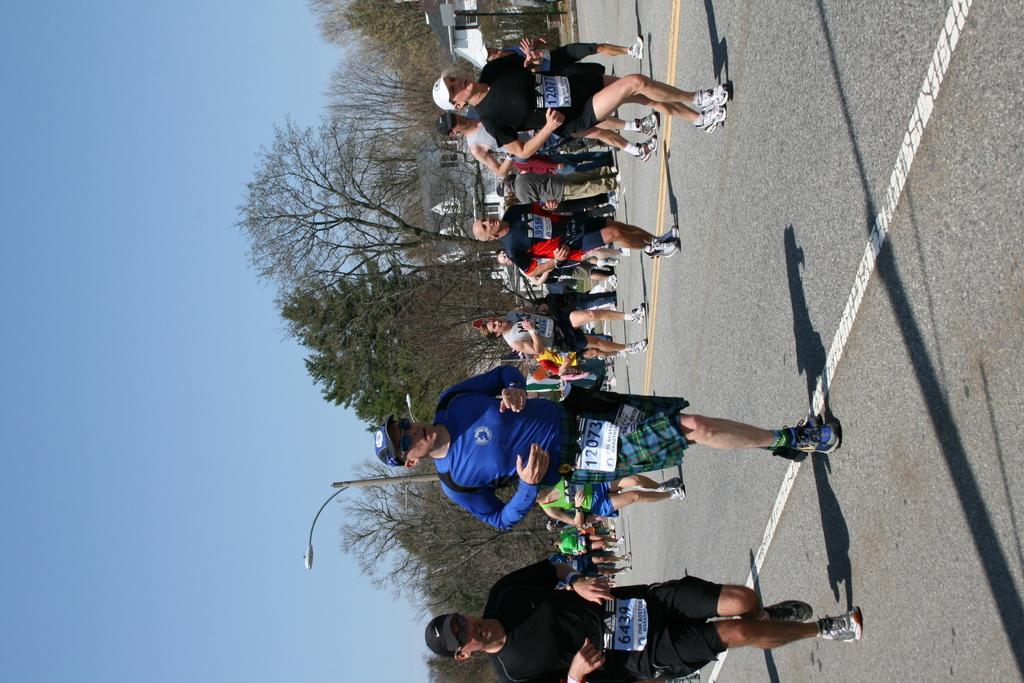How would you summarize this image in a sentence or two? On the right side of the picture it is road. In the center of the picture there are people running, on the road and there are trees, buildings and a street light. On the left it is sky. Sky is clear and it is sunny. 